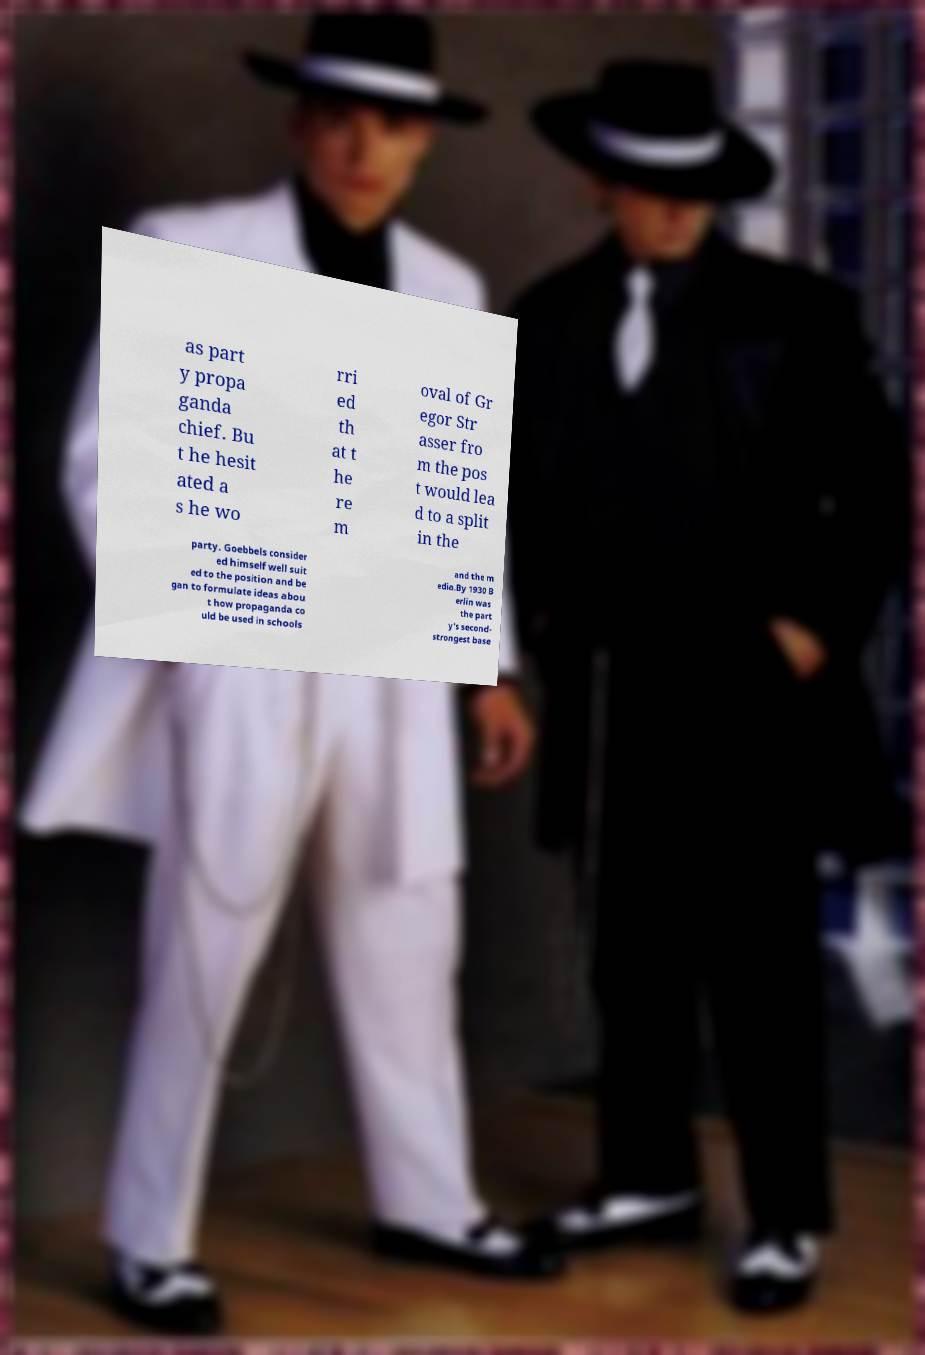I need the written content from this picture converted into text. Can you do that? as part y propa ganda chief. Bu t he hesit ated a s he wo rri ed th at t he re m oval of Gr egor Str asser fro m the pos t would lea d to a split in the party. Goebbels consider ed himself well suit ed to the position and be gan to formulate ideas abou t how propaganda co uld be used in schools and the m edia.By 1930 B erlin was the part y's second- strongest base 